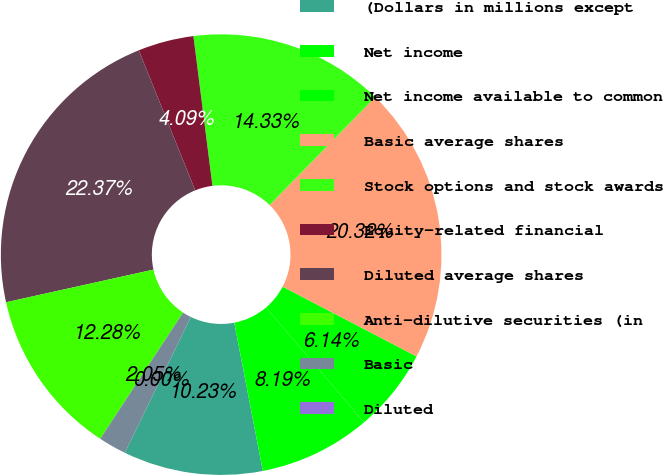<chart> <loc_0><loc_0><loc_500><loc_500><pie_chart><fcel>(Dollars in millions except<fcel>Net income<fcel>Net income available to common<fcel>Basic average shares<fcel>Stock options and stock awards<fcel>Equity-related financial<fcel>Diluted average shares<fcel>Anti-dilutive securities (in<fcel>Basic<fcel>Diluted<nl><fcel>10.23%<fcel>8.19%<fcel>6.14%<fcel>20.32%<fcel>14.33%<fcel>4.09%<fcel>22.37%<fcel>12.28%<fcel>2.05%<fcel>0.0%<nl></chart> 